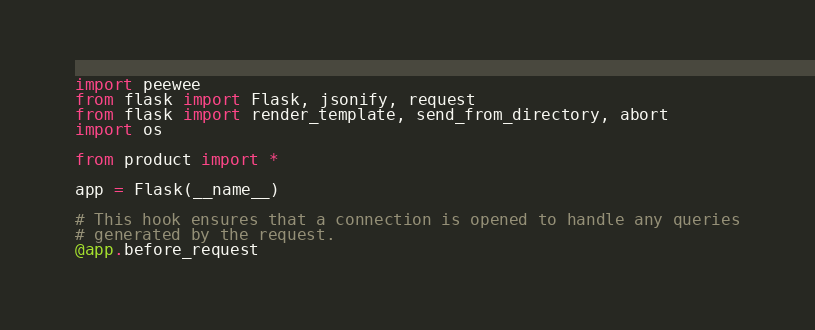<code> <loc_0><loc_0><loc_500><loc_500><_Python_>import peewee
from flask import Flask, jsonify, request
from flask import render_template, send_from_directory, abort
import os

from product import *

app = Flask(__name__)

# This hook ensures that a connection is opened to handle any queries
# generated by the request.
@app.before_request</code> 